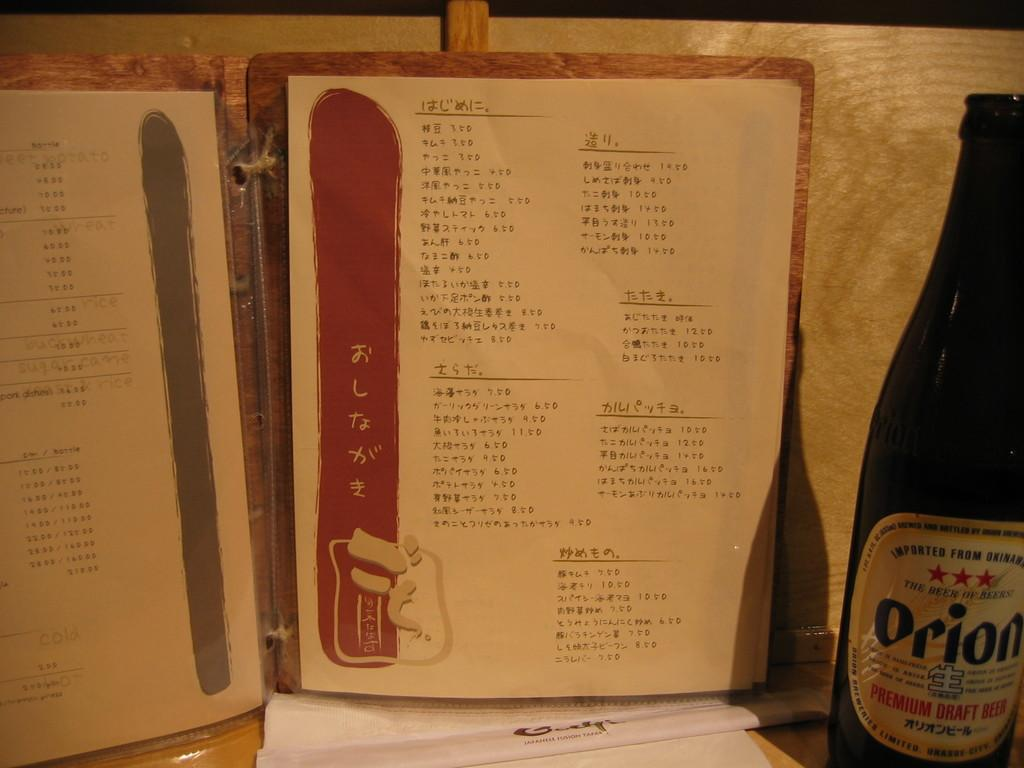<image>
Offer a succinct explanation of the picture presented. A bottle of Orion sits next to a paper written in a non-English language. 